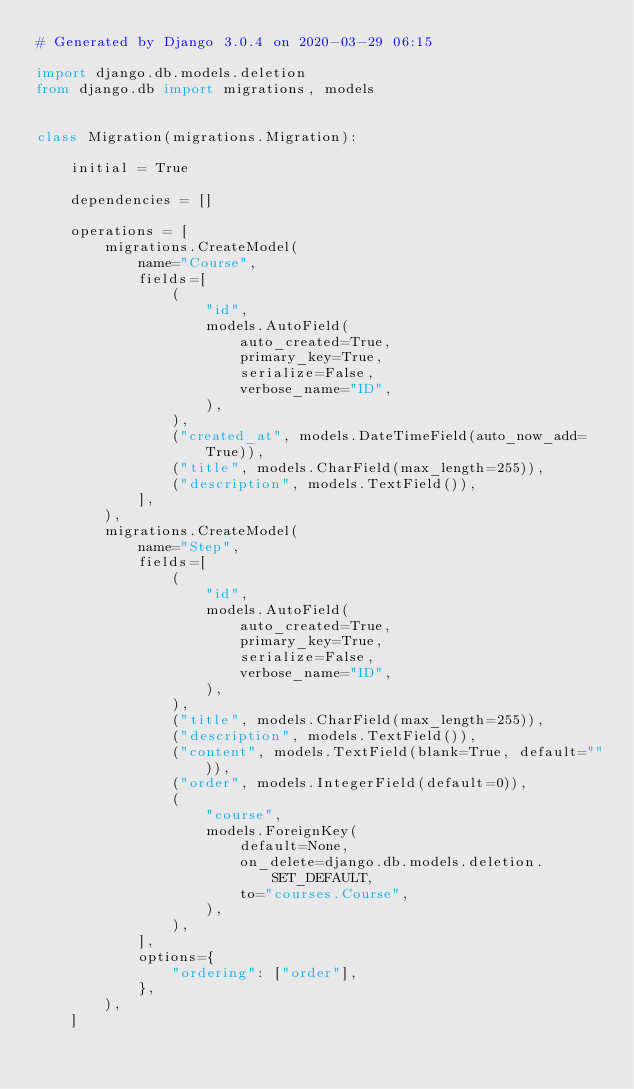<code> <loc_0><loc_0><loc_500><loc_500><_Python_># Generated by Django 3.0.4 on 2020-03-29 06:15

import django.db.models.deletion
from django.db import migrations, models


class Migration(migrations.Migration):

    initial = True

    dependencies = []

    operations = [
        migrations.CreateModel(
            name="Course",
            fields=[
                (
                    "id",
                    models.AutoField(
                        auto_created=True,
                        primary_key=True,
                        serialize=False,
                        verbose_name="ID",
                    ),
                ),
                ("created_at", models.DateTimeField(auto_now_add=True)),
                ("title", models.CharField(max_length=255)),
                ("description", models.TextField()),
            ],
        ),
        migrations.CreateModel(
            name="Step",
            fields=[
                (
                    "id",
                    models.AutoField(
                        auto_created=True,
                        primary_key=True,
                        serialize=False,
                        verbose_name="ID",
                    ),
                ),
                ("title", models.CharField(max_length=255)),
                ("description", models.TextField()),
                ("content", models.TextField(blank=True, default="")),
                ("order", models.IntegerField(default=0)),
                (
                    "course",
                    models.ForeignKey(
                        default=None,
                        on_delete=django.db.models.deletion.SET_DEFAULT,
                        to="courses.Course",
                    ),
                ),
            ],
            options={
                "ordering": ["order"],
            },
        ),
    ]
</code> 